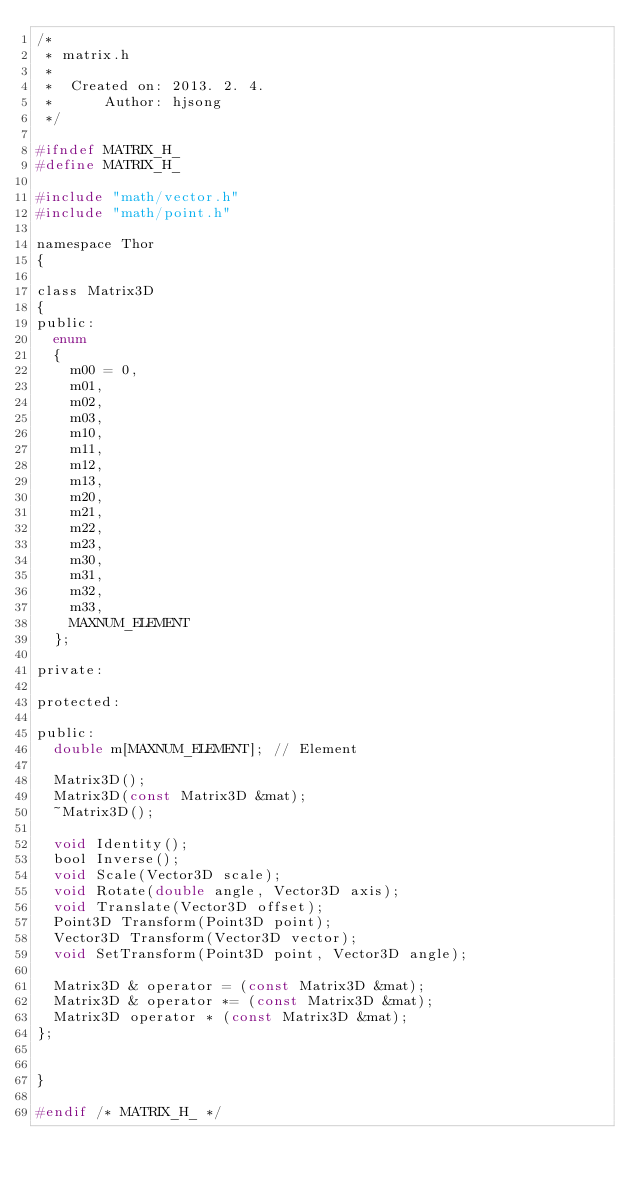<code> <loc_0><loc_0><loc_500><loc_500><_C_>/*
 * matrix.h
 *
 *  Created on: 2013. 2. 4.
 *      Author: hjsong
 */

#ifndef MATRIX_H_
#define MATRIX_H_

#include "math/vector.h"
#include "math/point.h"

namespace Thor
{

class Matrix3D
{
public:
	enum
	{
		m00 = 0,
		m01,
		m02,
		m03,
		m10,
		m11,
		m12,
		m13,
		m20,
		m21,
		m22,
		m23,
		m30,
		m31,
		m32,
		m33,
		MAXNUM_ELEMENT
	};

private:

protected:

public:
	double m[MAXNUM_ELEMENT]; // Element

	Matrix3D();
	Matrix3D(const Matrix3D &mat);
	~Matrix3D();

	void Identity();
	bool Inverse();
	void Scale(Vector3D scale);
	void Rotate(double angle, Vector3D axis);
	void Translate(Vector3D offset);
	Point3D Transform(Point3D point);
	Vector3D Transform(Vector3D vector);
	void SetTransform(Point3D point, Vector3D angle);

	Matrix3D & operator = (const Matrix3D &mat);
	Matrix3D & operator *= (const Matrix3D &mat);
	Matrix3D operator * (const Matrix3D &mat);
};


}

#endif /* MATRIX_H_ */
</code> 